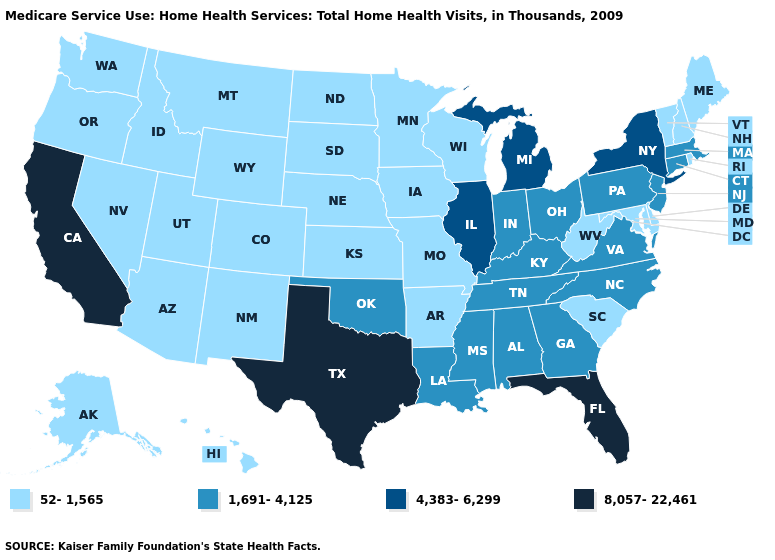What is the value of Oklahoma?
Short answer required. 1,691-4,125. What is the lowest value in the USA?
Short answer required. 52-1,565. Name the states that have a value in the range 1,691-4,125?
Write a very short answer. Alabama, Connecticut, Georgia, Indiana, Kentucky, Louisiana, Massachusetts, Mississippi, New Jersey, North Carolina, Ohio, Oklahoma, Pennsylvania, Tennessee, Virginia. What is the lowest value in states that border Iowa?
Quick response, please. 52-1,565. Name the states that have a value in the range 52-1,565?
Short answer required. Alaska, Arizona, Arkansas, Colorado, Delaware, Hawaii, Idaho, Iowa, Kansas, Maine, Maryland, Minnesota, Missouri, Montana, Nebraska, Nevada, New Hampshire, New Mexico, North Dakota, Oregon, Rhode Island, South Carolina, South Dakota, Utah, Vermont, Washington, West Virginia, Wisconsin, Wyoming. What is the value of New York?
Give a very brief answer. 4,383-6,299. What is the lowest value in the MidWest?
Write a very short answer. 52-1,565. Does Colorado have the same value as Montana?
Give a very brief answer. Yes. Does Washington have the lowest value in the USA?
Short answer required. Yes. Name the states that have a value in the range 52-1,565?
Concise answer only. Alaska, Arizona, Arkansas, Colorado, Delaware, Hawaii, Idaho, Iowa, Kansas, Maine, Maryland, Minnesota, Missouri, Montana, Nebraska, Nevada, New Hampshire, New Mexico, North Dakota, Oregon, Rhode Island, South Carolina, South Dakota, Utah, Vermont, Washington, West Virginia, Wisconsin, Wyoming. How many symbols are there in the legend?
Be succinct. 4. Does South Dakota have the same value as North Carolina?
Concise answer only. No. Does the first symbol in the legend represent the smallest category?
Keep it brief. Yes. What is the value of Massachusetts?
Quick response, please. 1,691-4,125. Name the states that have a value in the range 4,383-6,299?
Give a very brief answer. Illinois, Michigan, New York. 